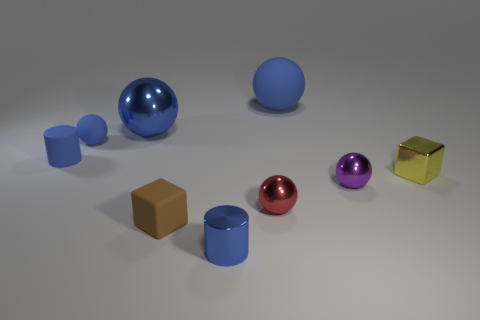Is there anything else that is the same size as the brown matte cube?
Give a very brief answer. Yes. What is the size of the blue rubber cylinder?
Offer a very short reply. Small. What number of tiny things are either rubber cylinders or green rubber blocks?
Your response must be concise. 1. There is a yellow cube; is its size the same as the cylinder right of the rubber cylinder?
Ensure brevity in your answer.  Yes. Are there any other things that are the same shape as the small yellow shiny thing?
Your answer should be compact. Yes. What number of big blue spheres are there?
Keep it short and to the point. 2. What number of cyan objects are small metal cylinders or cylinders?
Your answer should be compact. 0. Is the tiny block to the left of the metal cylinder made of the same material as the tiny blue ball?
Your response must be concise. Yes. How many other things are made of the same material as the tiny red ball?
Offer a terse response. 4. What is the material of the tiny red ball?
Your answer should be compact. Metal. 